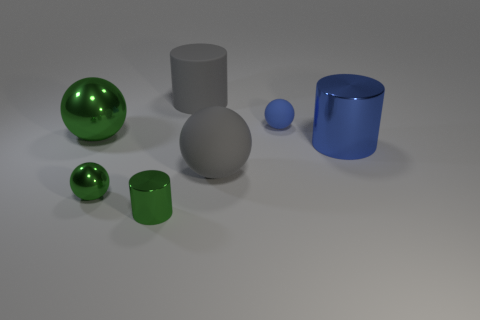Regarding the illumination in the scene, can you tell from which direction the light is coming? The light source seems to be coming primarily from the top-left side of the image, as indicated by the shadows cast to the right and slightly forward of the objects. 